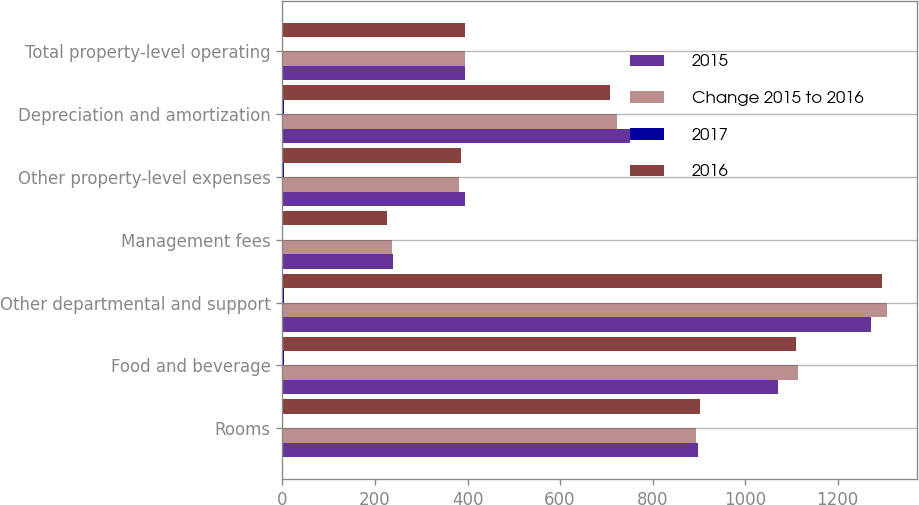<chart> <loc_0><loc_0><loc_500><loc_500><stacked_bar_chart><ecel><fcel>Rooms<fcel>Food and beverage<fcel>Other departmental and support<fcel>Management fees<fcel>Other property-level expenses<fcel>Depreciation and amortization<fcel>Total property-level operating<nl><fcel>2015<fcel>899<fcel>1071<fcel>1273<fcel>239<fcel>394<fcel>751<fcel>394<nl><fcel>Change 2015 to 2016<fcel>893<fcel>1114<fcel>1306<fcel>236<fcel>382<fcel>724<fcel>394<nl><fcel>2017<fcel>0.7<fcel>3.9<fcel>2.5<fcel>1.3<fcel>3.1<fcel>3.7<fcel>0.6<nl><fcel>2016<fcel>902<fcel>1110<fcel>1295<fcel>226<fcel>386<fcel>708<fcel>394<nl></chart> 